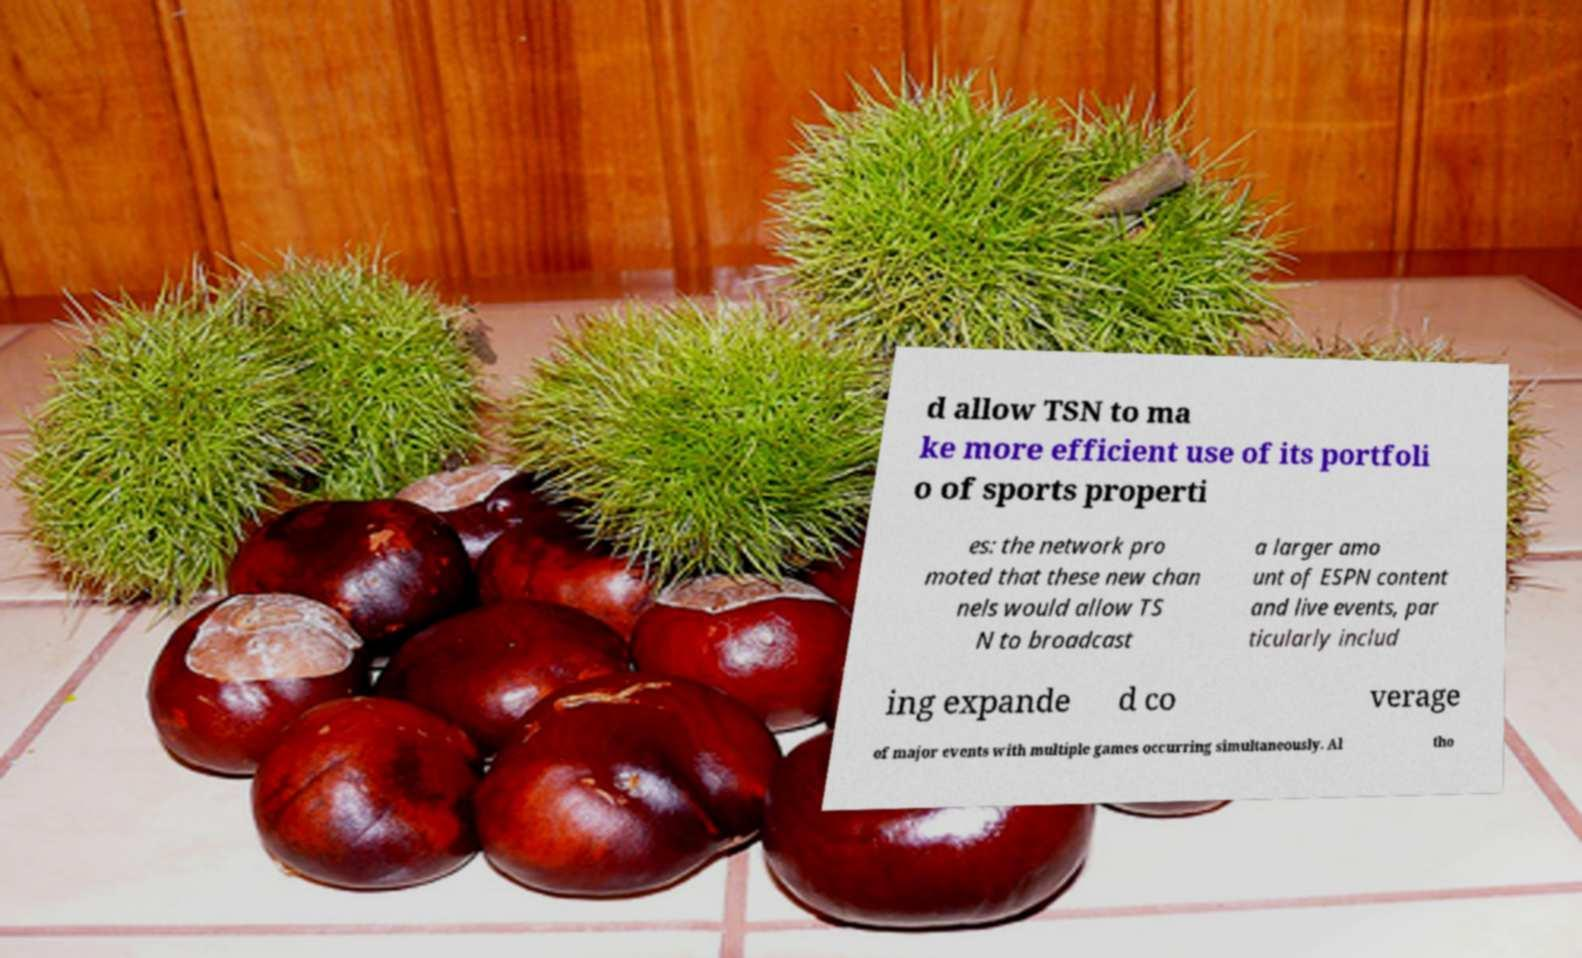Could you assist in decoding the text presented in this image and type it out clearly? d allow TSN to ma ke more efficient use of its portfoli o of sports properti es: the network pro moted that these new chan nels would allow TS N to broadcast a larger amo unt of ESPN content and live events, par ticularly includ ing expande d co verage of major events with multiple games occurring simultaneously. Al tho 